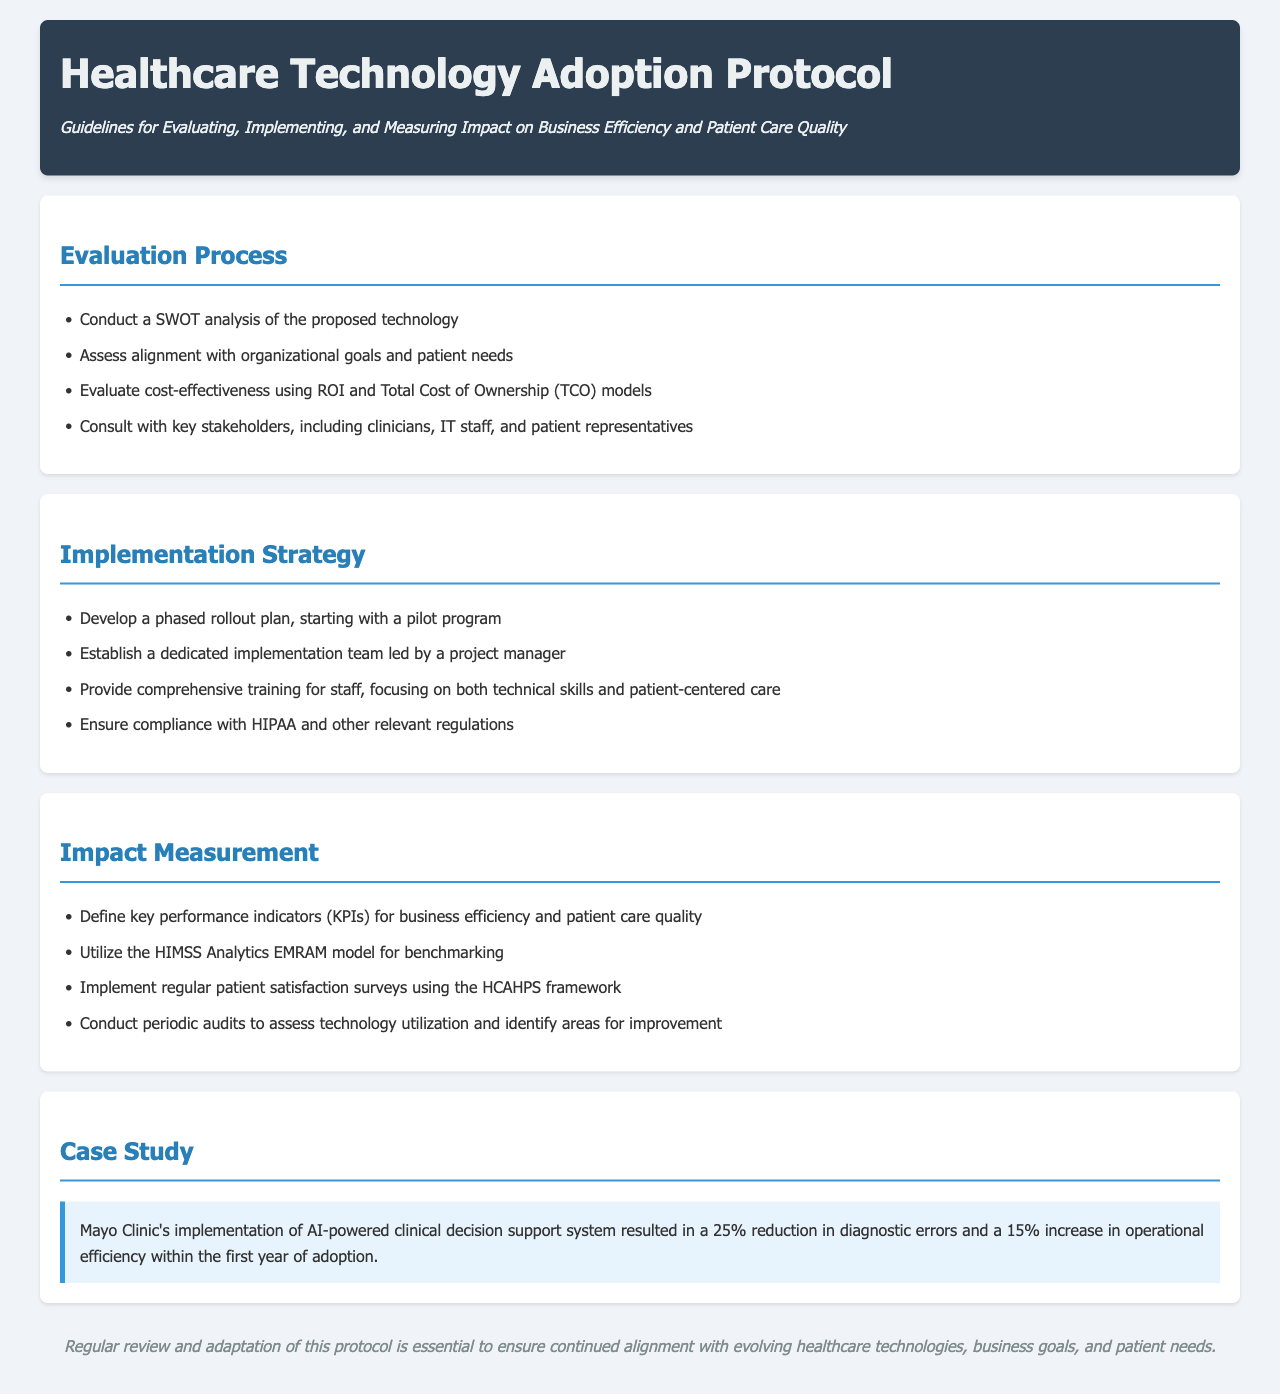What is the title of the document? The document's title is indicated in the header section, which is prominently displayed.
Answer: Healthcare Technology Adoption Protocol What is the first step in the evaluation process? The evaluation process begins with a specific analysis listed at the top of the section.
Answer: Conduct a SWOT analysis What are the key performance indicators referred to in the impact measurement section? The document outlines specific metrics to measure performance in the impact measurement section.
Answer: KPIs for business efficiency and patient care quality What technology implementation strategy involves starting with a pilot program? The implementation strategy is described in a specific step within that section.
Answer: Phased rollout plan Which organization is mentioned in the case study? The case study section includes a notable healthcare organization that successfully implemented a technology.
Answer: Mayo Clinic What is a necessary compliance requirement mentioned in the implementation strategy? The implementation strategy includes a specific legal compliance requirement that must be followed.
Answer: HIPAA How much was the reduction in diagnostic errors reported in the case study? The case study provides quantifiable results from the implemented technology in terms of error reduction.
Answer: 25% What framework is utilized for patient satisfaction surveys? The document specifies a framework that is used for gauging patient satisfaction.
Answer: HCAHPS What does the conclusion emphasize about the protocol? The conclusion provides a summary statement about the nature of the protocol's ongoing needs.
Answer: Regular review and adaptation 